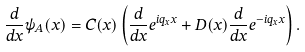Convert formula to latex. <formula><loc_0><loc_0><loc_500><loc_500>\frac { d } { d x } \psi _ { A } ( x ) = C ( x ) \left ( \frac { d } { d x } e ^ { i q _ { x } x } + D ( x ) \frac { d } { d x } e ^ { - i q _ { x } x } \right ) .</formula> 